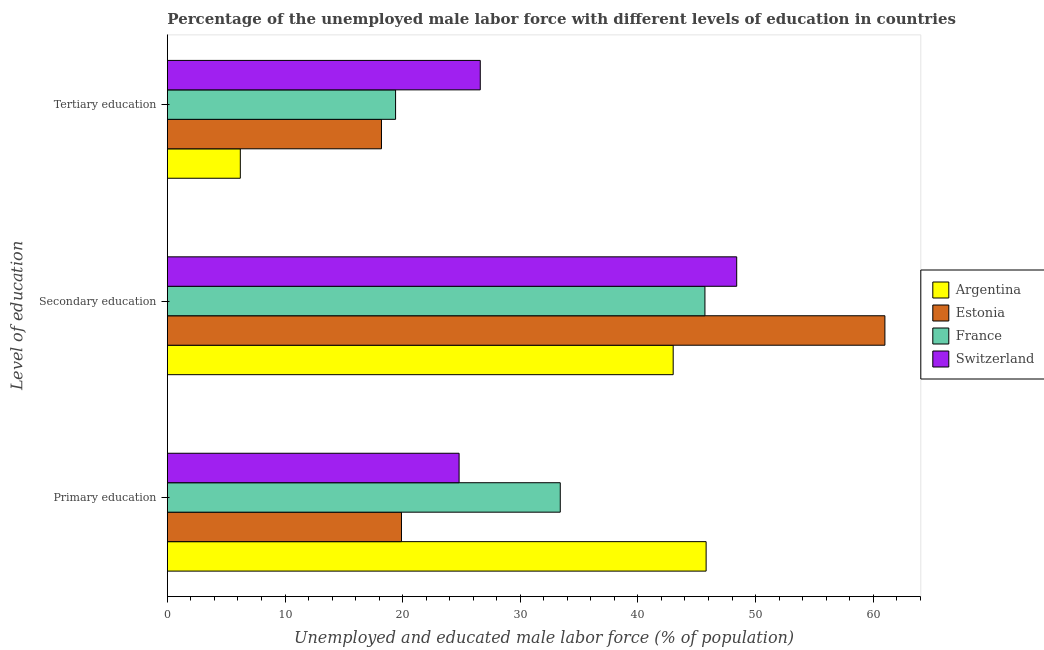How many groups of bars are there?
Offer a terse response. 3. What is the label of the 3rd group of bars from the top?
Your answer should be compact. Primary education. What is the percentage of male labor force who received tertiary education in Switzerland?
Your answer should be very brief. 26.6. Across all countries, what is the maximum percentage of male labor force who received tertiary education?
Your answer should be very brief. 26.6. Across all countries, what is the minimum percentage of male labor force who received tertiary education?
Your response must be concise. 6.2. In which country was the percentage of male labor force who received tertiary education maximum?
Keep it short and to the point. Switzerland. In which country was the percentage of male labor force who received primary education minimum?
Give a very brief answer. Estonia. What is the total percentage of male labor force who received primary education in the graph?
Make the answer very short. 123.9. What is the difference between the percentage of male labor force who received secondary education in Switzerland and that in Estonia?
Provide a succinct answer. -12.6. What is the difference between the percentage of male labor force who received tertiary education in Estonia and the percentage of male labor force who received primary education in France?
Your answer should be compact. -15.2. What is the average percentage of male labor force who received secondary education per country?
Your answer should be compact. 49.53. What is the difference between the percentage of male labor force who received secondary education and percentage of male labor force who received tertiary education in Estonia?
Make the answer very short. 42.8. In how many countries, is the percentage of male labor force who received tertiary education greater than 56 %?
Give a very brief answer. 0. What is the ratio of the percentage of male labor force who received tertiary education in Switzerland to that in Estonia?
Offer a terse response. 1.46. Is the percentage of male labor force who received tertiary education in Argentina less than that in France?
Your response must be concise. Yes. What is the difference between the highest and the second highest percentage of male labor force who received tertiary education?
Ensure brevity in your answer.  7.2. What is the difference between the highest and the lowest percentage of male labor force who received primary education?
Your answer should be compact. 25.9. In how many countries, is the percentage of male labor force who received tertiary education greater than the average percentage of male labor force who received tertiary education taken over all countries?
Your answer should be compact. 3. What does the 3rd bar from the top in Tertiary education represents?
Your answer should be compact. Estonia. What does the 4th bar from the bottom in Tertiary education represents?
Your answer should be compact. Switzerland. How many bars are there?
Provide a succinct answer. 12. What is the difference between two consecutive major ticks on the X-axis?
Make the answer very short. 10. Are the values on the major ticks of X-axis written in scientific E-notation?
Offer a very short reply. No. Where does the legend appear in the graph?
Your answer should be very brief. Center right. What is the title of the graph?
Keep it short and to the point. Percentage of the unemployed male labor force with different levels of education in countries. What is the label or title of the X-axis?
Offer a terse response. Unemployed and educated male labor force (% of population). What is the label or title of the Y-axis?
Provide a succinct answer. Level of education. What is the Unemployed and educated male labor force (% of population) in Argentina in Primary education?
Ensure brevity in your answer.  45.8. What is the Unemployed and educated male labor force (% of population) in Estonia in Primary education?
Offer a terse response. 19.9. What is the Unemployed and educated male labor force (% of population) of France in Primary education?
Keep it short and to the point. 33.4. What is the Unemployed and educated male labor force (% of population) in Switzerland in Primary education?
Your answer should be compact. 24.8. What is the Unemployed and educated male labor force (% of population) of Estonia in Secondary education?
Provide a succinct answer. 61. What is the Unemployed and educated male labor force (% of population) in France in Secondary education?
Provide a succinct answer. 45.7. What is the Unemployed and educated male labor force (% of population) of Switzerland in Secondary education?
Provide a succinct answer. 48.4. What is the Unemployed and educated male labor force (% of population) in Argentina in Tertiary education?
Provide a succinct answer. 6.2. What is the Unemployed and educated male labor force (% of population) of Estonia in Tertiary education?
Your answer should be compact. 18.2. What is the Unemployed and educated male labor force (% of population) in France in Tertiary education?
Make the answer very short. 19.4. What is the Unemployed and educated male labor force (% of population) of Switzerland in Tertiary education?
Offer a very short reply. 26.6. Across all Level of education, what is the maximum Unemployed and educated male labor force (% of population) in Argentina?
Offer a very short reply. 45.8. Across all Level of education, what is the maximum Unemployed and educated male labor force (% of population) in Estonia?
Offer a terse response. 61. Across all Level of education, what is the maximum Unemployed and educated male labor force (% of population) of France?
Offer a terse response. 45.7. Across all Level of education, what is the maximum Unemployed and educated male labor force (% of population) of Switzerland?
Your answer should be compact. 48.4. Across all Level of education, what is the minimum Unemployed and educated male labor force (% of population) of Argentina?
Your answer should be compact. 6.2. Across all Level of education, what is the minimum Unemployed and educated male labor force (% of population) of Estonia?
Keep it short and to the point. 18.2. Across all Level of education, what is the minimum Unemployed and educated male labor force (% of population) of France?
Offer a very short reply. 19.4. Across all Level of education, what is the minimum Unemployed and educated male labor force (% of population) in Switzerland?
Your response must be concise. 24.8. What is the total Unemployed and educated male labor force (% of population) of Estonia in the graph?
Provide a short and direct response. 99.1. What is the total Unemployed and educated male labor force (% of population) in France in the graph?
Provide a short and direct response. 98.5. What is the total Unemployed and educated male labor force (% of population) of Switzerland in the graph?
Make the answer very short. 99.8. What is the difference between the Unemployed and educated male labor force (% of population) in Estonia in Primary education and that in Secondary education?
Provide a short and direct response. -41.1. What is the difference between the Unemployed and educated male labor force (% of population) of France in Primary education and that in Secondary education?
Your answer should be compact. -12.3. What is the difference between the Unemployed and educated male labor force (% of population) in Switzerland in Primary education and that in Secondary education?
Your answer should be very brief. -23.6. What is the difference between the Unemployed and educated male labor force (% of population) in Argentina in Primary education and that in Tertiary education?
Provide a short and direct response. 39.6. What is the difference between the Unemployed and educated male labor force (% of population) of Argentina in Secondary education and that in Tertiary education?
Provide a succinct answer. 36.8. What is the difference between the Unemployed and educated male labor force (% of population) of Estonia in Secondary education and that in Tertiary education?
Your answer should be very brief. 42.8. What is the difference between the Unemployed and educated male labor force (% of population) in France in Secondary education and that in Tertiary education?
Provide a succinct answer. 26.3. What is the difference between the Unemployed and educated male labor force (% of population) of Switzerland in Secondary education and that in Tertiary education?
Your answer should be very brief. 21.8. What is the difference between the Unemployed and educated male labor force (% of population) of Argentina in Primary education and the Unemployed and educated male labor force (% of population) of Estonia in Secondary education?
Your answer should be compact. -15.2. What is the difference between the Unemployed and educated male labor force (% of population) of Estonia in Primary education and the Unemployed and educated male labor force (% of population) of France in Secondary education?
Your answer should be compact. -25.8. What is the difference between the Unemployed and educated male labor force (% of population) of Estonia in Primary education and the Unemployed and educated male labor force (% of population) of Switzerland in Secondary education?
Your answer should be compact. -28.5. What is the difference between the Unemployed and educated male labor force (% of population) in Argentina in Primary education and the Unemployed and educated male labor force (% of population) in Estonia in Tertiary education?
Your answer should be very brief. 27.6. What is the difference between the Unemployed and educated male labor force (% of population) in Argentina in Primary education and the Unemployed and educated male labor force (% of population) in France in Tertiary education?
Offer a terse response. 26.4. What is the difference between the Unemployed and educated male labor force (% of population) of Estonia in Primary education and the Unemployed and educated male labor force (% of population) of France in Tertiary education?
Your answer should be very brief. 0.5. What is the difference between the Unemployed and educated male labor force (% of population) of Estonia in Primary education and the Unemployed and educated male labor force (% of population) of Switzerland in Tertiary education?
Keep it short and to the point. -6.7. What is the difference between the Unemployed and educated male labor force (% of population) of Argentina in Secondary education and the Unemployed and educated male labor force (% of population) of Estonia in Tertiary education?
Keep it short and to the point. 24.8. What is the difference between the Unemployed and educated male labor force (% of population) of Argentina in Secondary education and the Unemployed and educated male labor force (% of population) of France in Tertiary education?
Make the answer very short. 23.6. What is the difference between the Unemployed and educated male labor force (% of population) of Argentina in Secondary education and the Unemployed and educated male labor force (% of population) of Switzerland in Tertiary education?
Provide a short and direct response. 16.4. What is the difference between the Unemployed and educated male labor force (% of population) in Estonia in Secondary education and the Unemployed and educated male labor force (% of population) in France in Tertiary education?
Provide a short and direct response. 41.6. What is the difference between the Unemployed and educated male labor force (% of population) in Estonia in Secondary education and the Unemployed and educated male labor force (% of population) in Switzerland in Tertiary education?
Provide a short and direct response. 34.4. What is the average Unemployed and educated male labor force (% of population) of Argentina per Level of education?
Give a very brief answer. 31.67. What is the average Unemployed and educated male labor force (% of population) of Estonia per Level of education?
Keep it short and to the point. 33.03. What is the average Unemployed and educated male labor force (% of population) of France per Level of education?
Your response must be concise. 32.83. What is the average Unemployed and educated male labor force (% of population) in Switzerland per Level of education?
Make the answer very short. 33.27. What is the difference between the Unemployed and educated male labor force (% of population) of Argentina and Unemployed and educated male labor force (% of population) of Estonia in Primary education?
Give a very brief answer. 25.9. What is the difference between the Unemployed and educated male labor force (% of population) of Argentina and Unemployed and educated male labor force (% of population) of France in Primary education?
Your response must be concise. 12.4. What is the difference between the Unemployed and educated male labor force (% of population) of Estonia and Unemployed and educated male labor force (% of population) of France in Primary education?
Ensure brevity in your answer.  -13.5. What is the difference between the Unemployed and educated male labor force (% of population) of France and Unemployed and educated male labor force (% of population) of Switzerland in Primary education?
Give a very brief answer. 8.6. What is the difference between the Unemployed and educated male labor force (% of population) of Argentina and Unemployed and educated male labor force (% of population) of Estonia in Tertiary education?
Offer a terse response. -12. What is the difference between the Unemployed and educated male labor force (% of population) of Argentina and Unemployed and educated male labor force (% of population) of France in Tertiary education?
Offer a terse response. -13.2. What is the difference between the Unemployed and educated male labor force (% of population) of Argentina and Unemployed and educated male labor force (% of population) of Switzerland in Tertiary education?
Provide a short and direct response. -20.4. What is the ratio of the Unemployed and educated male labor force (% of population) in Argentina in Primary education to that in Secondary education?
Your answer should be very brief. 1.07. What is the ratio of the Unemployed and educated male labor force (% of population) in Estonia in Primary education to that in Secondary education?
Offer a terse response. 0.33. What is the ratio of the Unemployed and educated male labor force (% of population) of France in Primary education to that in Secondary education?
Provide a short and direct response. 0.73. What is the ratio of the Unemployed and educated male labor force (% of population) of Switzerland in Primary education to that in Secondary education?
Your response must be concise. 0.51. What is the ratio of the Unemployed and educated male labor force (% of population) of Argentina in Primary education to that in Tertiary education?
Your response must be concise. 7.39. What is the ratio of the Unemployed and educated male labor force (% of population) of Estonia in Primary education to that in Tertiary education?
Ensure brevity in your answer.  1.09. What is the ratio of the Unemployed and educated male labor force (% of population) in France in Primary education to that in Tertiary education?
Provide a short and direct response. 1.72. What is the ratio of the Unemployed and educated male labor force (% of population) of Switzerland in Primary education to that in Tertiary education?
Give a very brief answer. 0.93. What is the ratio of the Unemployed and educated male labor force (% of population) in Argentina in Secondary education to that in Tertiary education?
Provide a short and direct response. 6.94. What is the ratio of the Unemployed and educated male labor force (% of population) in Estonia in Secondary education to that in Tertiary education?
Ensure brevity in your answer.  3.35. What is the ratio of the Unemployed and educated male labor force (% of population) of France in Secondary education to that in Tertiary education?
Make the answer very short. 2.36. What is the ratio of the Unemployed and educated male labor force (% of population) in Switzerland in Secondary education to that in Tertiary education?
Give a very brief answer. 1.82. What is the difference between the highest and the second highest Unemployed and educated male labor force (% of population) in Estonia?
Offer a very short reply. 41.1. What is the difference between the highest and the second highest Unemployed and educated male labor force (% of population) of Switzerland?
Your response must be concise. 21.8. What is the difference between the highest and the lowest Unemployed and educated male labor force (% of population) in Argentina?
Make the answer very short. 39.6. What is the difference between the highest and the lowest Unemployed and educated male labor force (% of population) in Estonia?
Offer a very short reply. 42.8. What is the difference between the highest and the lowest Unemployed and educated male labor force (% of population) of France?
Give a very brief answer. 26.3. What is the difference between the highest and the lowest Unemployed and educated male labor force (% of population) in Switzerland?
Your response must be concise. 23.6. 